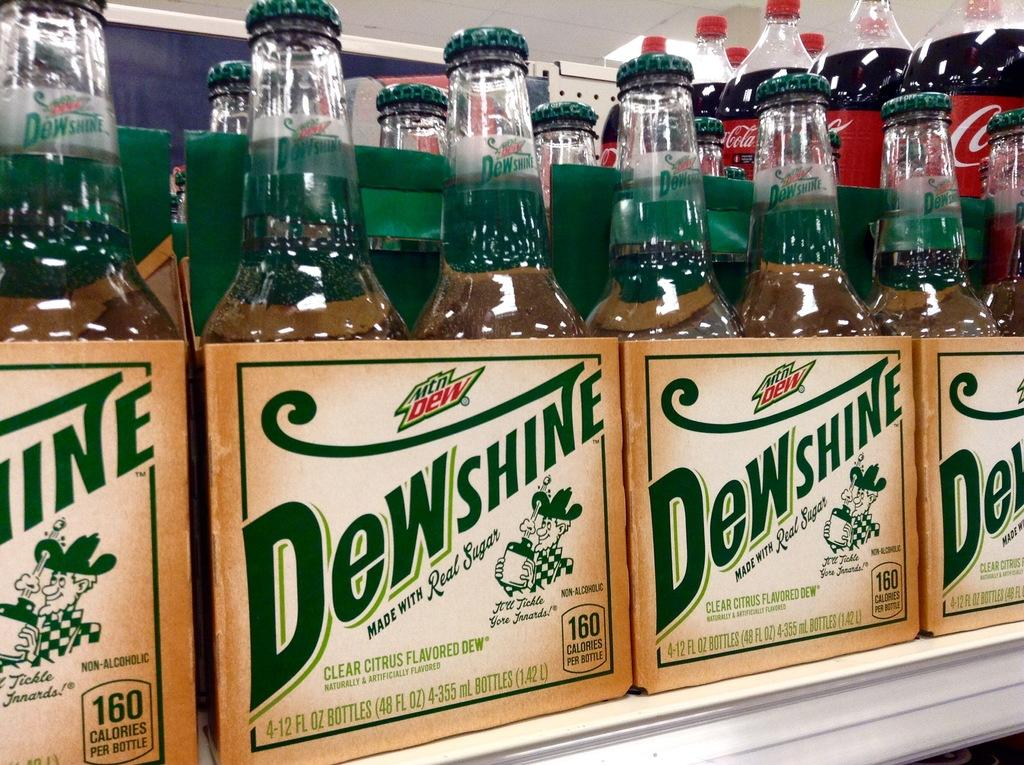Provide a one-sentence caption for the provided image. A shelf with Dewshine alcohol in 4 pack boxes. 